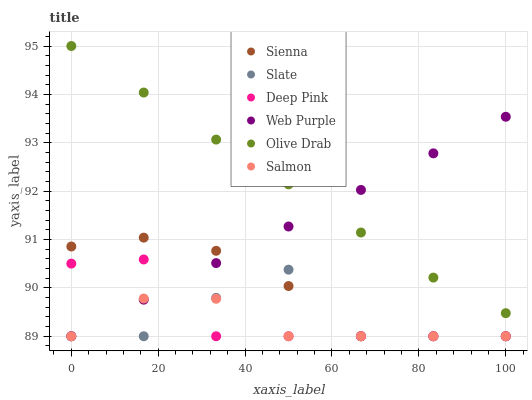Does Salmon have the minimum area under the curve?
Answer yes or no. Yes. Does Olive Drab have the maximum area under the curve?
Answer yes or no. Yes. Does Slate have the minimum area under the curve?
Answer yes or no. No. Does Slate have the maximum area under the curve?
Answer yes or no. No. Is Web Purple the smoothest?
Answer yes or no. Yes. Is Slate the roughest?
Answer yes or no. Yes. Is Salmon the smoothest?
Answer yes or no. No. Is Salmon the roughest?
Answer yes or no. No. Does Deep Pink have the lowest value?
Answer yes or no. Yes. Does Olive Drab have the lowest value?
Answer yes or no. No. Does Olive Drab have the highest value?
Answer yes or no. Yes. Does Slate have the highest value?
Answer yes or no. No. Is Slate less than Olive Drab?
Answer yes or no. Yes. Is Olive Drab greater than Deep Pink?
Answer yes or no. Yes. Does Sienna intersect Web Purple?
Answer yes or no. Yes. Is Sienna less than Web Purple?
Answer yes or no. No. Is Sienna greater than Web Purple?
Answer yes or no. No. Does Slate intersect Olive Drab?
Answer yes or no. No. 